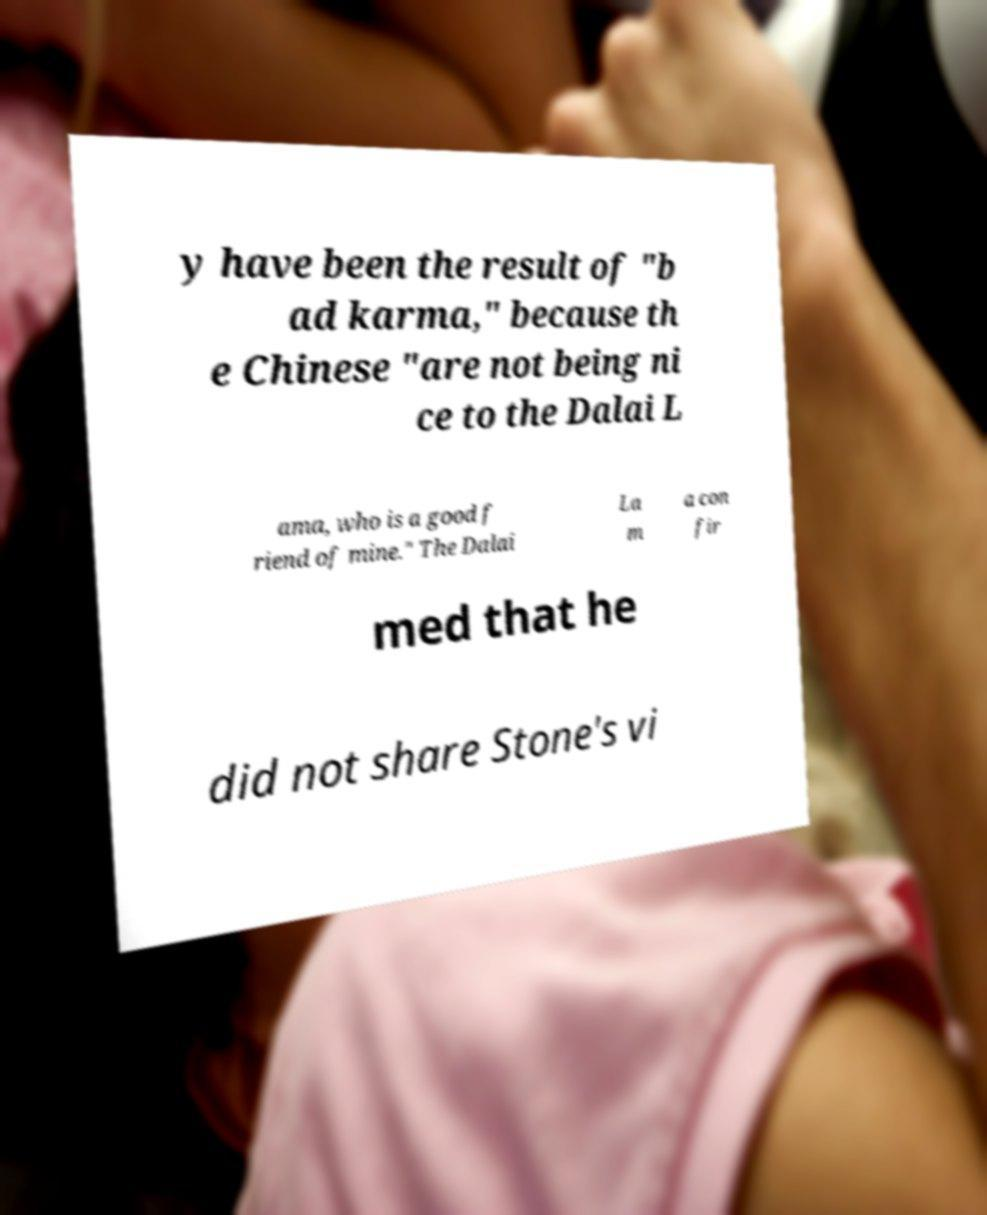Can you read and provide the text displayed in the image?This photo seems to have some interesting text. Can you extract and type it out for me? y have been the result of "b ad karma," because th e Chinese "are not being ni ce to the Dalai L ama, who is a good f riend of mine." The Dalai La m a con fir med that he did not share Stone's vi 